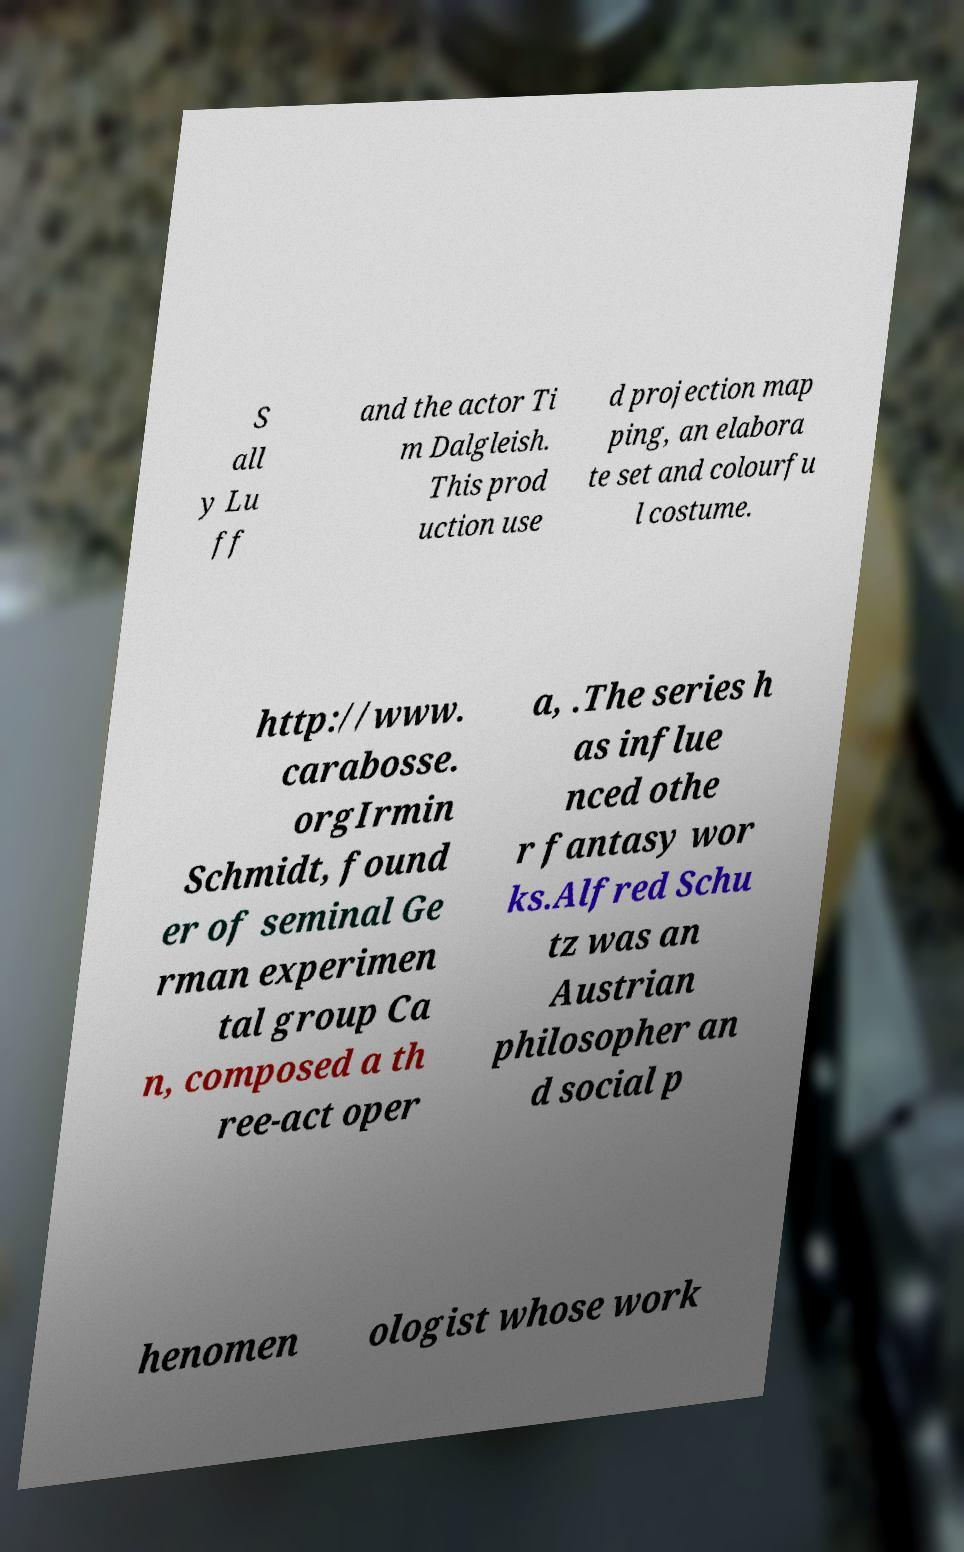Can you accurately transcribe the text from the provided image for me? S all y Lu ff and the actor Ti m Dalgleish. This prod uction use d projection map ping, an elabora te set and colourfu l costume. http://www. carabosse. orgIrmin Schmidt, found er of seminal Ge rman experimen tal group Ca n, composed a th ree-act oper a, .The series h as influe nced othe r fantasy wor ks.Alfred Schu tz was an Austrian philosopher an d social p henomen ologist whose work 